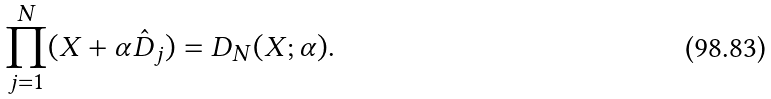<formula> <loc_0><loc_0><loc_500><loc_500>\prod _ { j = 1 } ^ { N } ( X + \alpha \hat { D } _ { j } ) = D _ { N } ( X ; \alpha ) .</formula> 